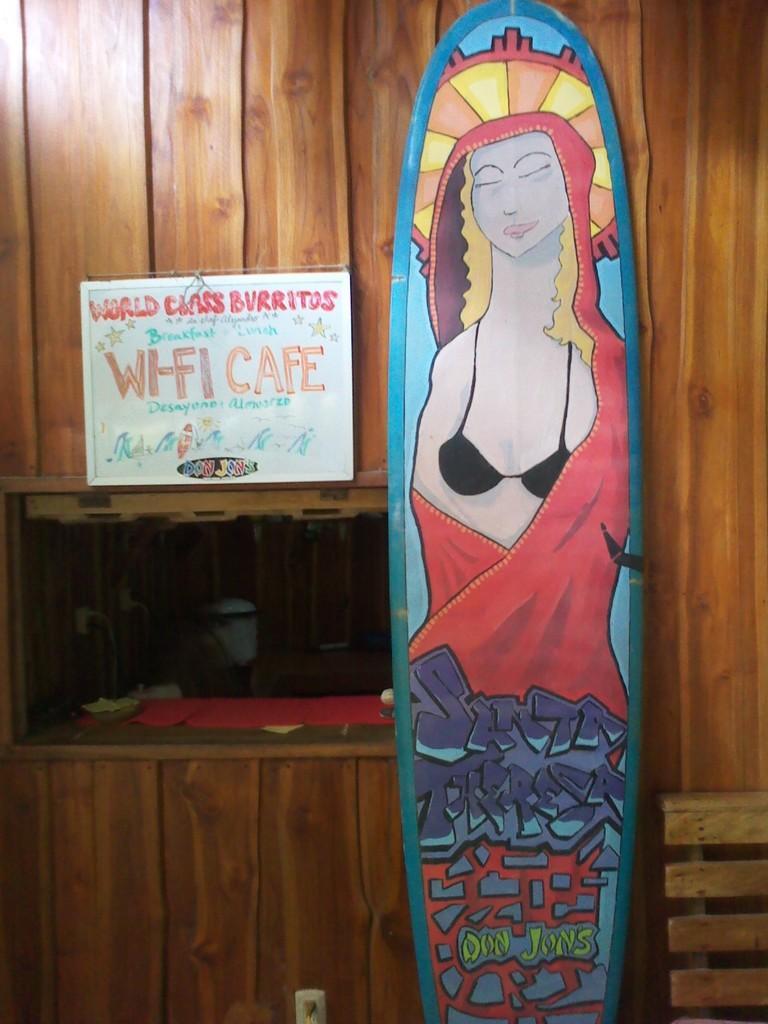How would you summarize this image in a sentence or two? In the center of the image we can see one board with some painting on it. In the painting, we can see one person and some text. In the background, there is a wooden wall, one board with some text and a few other objects. 